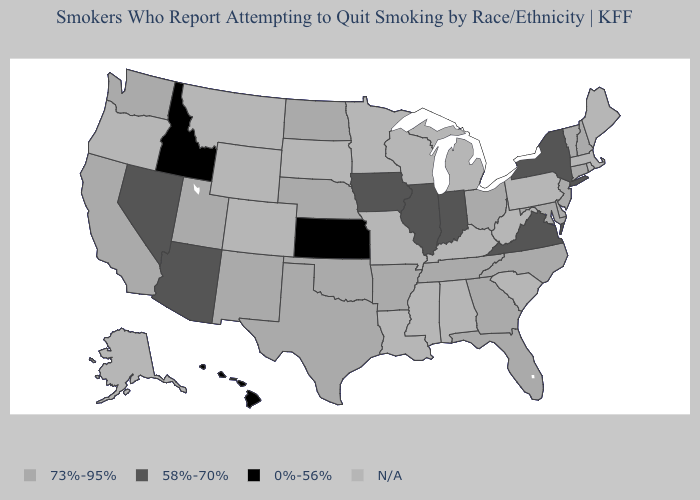What is the value of South Dakota?
Be succinct. N/A. Name the states that have a value in the range 0%-56%?
Give a very brief answer. Hawaii, Idaho, Kansas. Which states hav the highest value in the South?
Answer briefly. Arkansas, Delaware, Florida, Georgia, Maryland, North Carolina, Oklahoma, Tennessee, Texas. Name the states that have a value in the range N/A?
Be succinct. Alabama, Alaska, Colorado, Kentucky, Louisiana, Maine, Massachusetts, Michigan, Minnesota, Mississippi, Missouri, Montana, Oregon, Pennsylvania, Rhode Island, South Carolina, South Dakota, West Virginia, Wisconsin, Wyoming. Which states have the lowest value in the West?
Short answer required. Hawaii, Idaho. Name the states that have a value in the range 73%-95%?
Write a very short answer. Arkansas, California, Connecticut, Delaware, Florida, Georgia, Maryland, Nebraska, New Hampshire, New Jersey, New Mexico, North Carolina, North Dakota, Ohio, Oklahoma, Tennessee, Texas, Utah, Vermont, Washington. Name the states that have a value in the range 58%-70%?
Answer briefly. Arizona, Illinois, Indiana, Iowa, Nevada, New York, Virginia. How many symbols are there in the legend?
Quick response, please. 4. What is the lowest value in the West?
Write a very short answer. 0%-56%. What is the value of Rhode Island?
Write a very short answer. N/A. What is the value of Montana?
Quick response, please. N/A. Does Hawaii have the lowest value in the USA?
Concise answer only. Yes. Among the states that border New Mexico , does Utah have the lowest value?
Write a very short answer. No. 